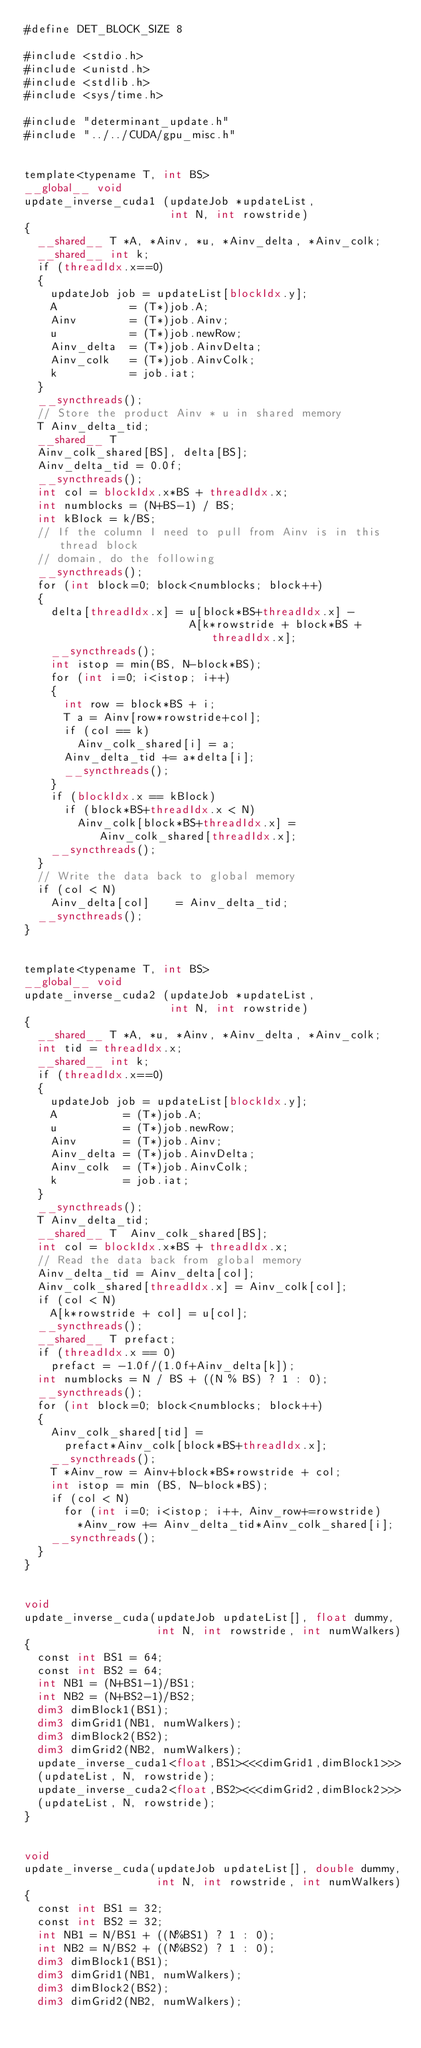Convert code to text. <code><loc_0><loc_0><loc_500><loc_500><_Cuda_>#define DET_BLOCK_SIZE 8

#include <stdio.h>
#include <unistd.h>
#include <stdlib.h>
#include <sys/time.h>

#include "determinant_update.h"
#include "../../CUDA/gpu_misc.h"


template<typename T, int BS>
__global__ void
update_inverse_cuda1 (updateJob *updateList,
                      int N, int rowstride)
{
  __shared__ T *A, *Ainv, *u, *Ainv_delta, *Ainv_colk;
  __shared__ int k;
  if (threadIdx.x==0)
  {
    updateJob job = updateList[blockIdx.y];
    A           = (T*)job.A;
    Ainv        = (T*)job.Ainv;
    u           = (T*)job.newRow;
    Ainv_delta  = (T*)job.AinvDelta;
    Ainv_colk   = (T*)job.AinvColk;
    k           = job.iat;
  }
  __syncthreads();
  // Store the product Ainv * u in shared memory
  T Ainv_delta_tid;
  __shared__ T
  Ainv_colk_shared[BS], delta[BS];
  Ainv_delta_tid = 0.0f;
  __syncthreads();
  int col = blockIdx.x*BS + threadIdx.x;
  int numblocks = (N+BS-1) / BS;
  int kBlock = k/BS;
  // If the column I need to pull from Ainv is in this thread block
  // domain, do the following
  __syncthreads();
  for (int block=0; block<numblocks; block++)
  {
    delta[threadIdx.x] = u[block*BS+threadIdx.x] -
                         A[k*rowstride + block*BS + threadIdx.x];
    __syncthreads();
    int istop = min(BS, N-block*BS);
    for (int i=0; i<istop; i++)
    {
      int row = block*BS + i;
      T a = Ainv[row*rowstride+col];
      if (col == k)
        Ainv_colk_shared[i] = a;
      Ainv_delta_tid += a*delta[i];
      __syncthreads();
    }
    if (blockIdx.x == kBlock)
      if (block*BS+threadIdx.x < N)
        Ainv_colk[block*BS+threadIdx.x] = Ainv_colk_shared[threadIdx.x];
    __syncthreads();
  }
  // Write the data back to global memory
  if (col < N)
    Ainv_delta[col]    = Ainv_delta_tid;
  __syncthreads();
}


template<typename T, int BS>
__global__ void
update_inverse_cuda2 (updateJob *updateList,
                      int N, int rowstride)
{
  __shared__ T *A, *u, *Ainv, *Ainv_delta, *Ainv_colk;
  int tid = threadIdx.x;
  __shared__ int k;
  if (threadIdx.x==0)
  {
    updateJob job = updateList[blockIdx.y];
    A          = (T*)job.A;
    u          = (T*)job.newRow;
    Ainv       = (T*)job.Ainv;
    Ainv_delta = (T*)job.AinvDelta;
    Ainv_colk  = (T*)job.AinvColk;
    k          = job.iat;
  }
  __syncthreads();
  T Ainv_delta_tid;
  __shared__ T  Ainv_colk_shared[BS];
  int col = blockIdx.x*BS + threadIdx.x;
  // Read the data back from global memory
  Ainv_delta_tid = Ainv_delta[col];
  Ainv_colk_shared[threadIdx.x] = Ainv_colk[col];
  if (col < N)
    A[k*rowstride + col] = u[col];
  __syncthreads();
  __shared__ T prefact;
  if (threadIdx.x == 0)
    prefact = -1.0f/(1.0f+Ainv_delta[k]);
  int numblocks = N / BS + ((N % BS) ? 1 : 0);
  __syncthreads();
  for (int block=0; block<numblocks; block++)
  {
    Ainv_colk_shared[tid] =
      prefact*Ainv_colk[block*BS+threadIdx.x];
    __syncthreads();
    T *Ainv_row = Ainv+block*BS*rowstride + col;
    int istop = min (BS, N-block*BS);
    if (col < N)
      for (int i=0; i<istop; i++, Ainv_row+=rowstride)
        *Ainv_row += Ainv_delta_tid*Ainv_colk_shared[i];
    __syncthreads();
  }
}


void
update_inverse_cuda(updateJob updateList[], float dummy,
                    int N, int rowstride, int numWalkers)
{
  const int BS1 = 64;
  const int BS2 = 64;
  int NB1 = (N+BS1-1)/BS1;
  int NB2 = (N+BS2-1)/BS2;
  dim3 dimBlock1(BS1);
  dim3 dimGrid1(NB1, numWalkers);
  dim3 dimBlock2(BS2);
  dim3 dimGrid2(NB2, numWalkers);
  update_inverse_cuda1<float,BS1><<<dimGrid1,dimBlock1>>>
  (updateList, N, rowstride);
  update_inverse_cuda2<float,BS2><<<dimGrid2,dimBlock2>>>
  (updateList, N, rowstride);
}


void
update_inverse_cuda(updateJob updateList[], double dummy,
                    int N, int rowstride, int numWalkers)
{
  const int BS1 = 32;
  const int BS2 = 32;
  int NB1 = N/BS1 + ((N%BS1) ? 1 : 0);
  int NB2 = N/BS2 + ((N%BS2) ? 1 : 0);
  dim3 dimBlock1(BS1);
  dim3 dimGrid1(NB1, numWalkers);
  dim3 dimBlock2(BS2);
  dim3 dimGrid2(NB2, numWalkers);</code> 